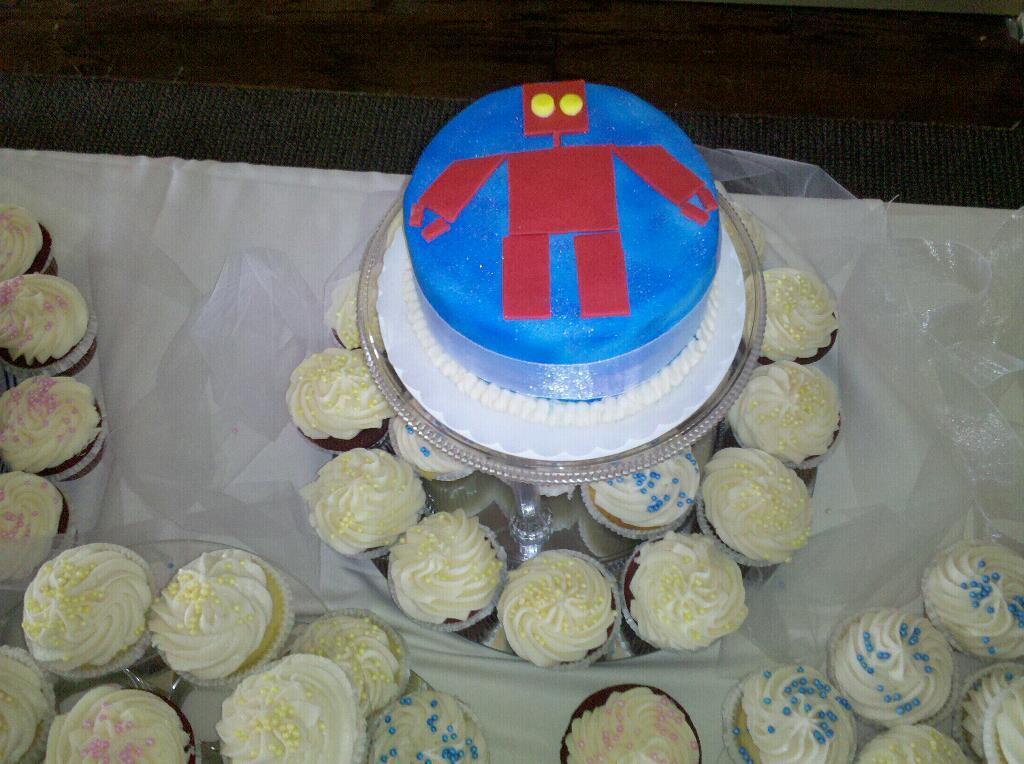Can you describe this image briefly? In this image, we can see cupcakes and jars which are placed on the table. At the bottom, there is carpet. 